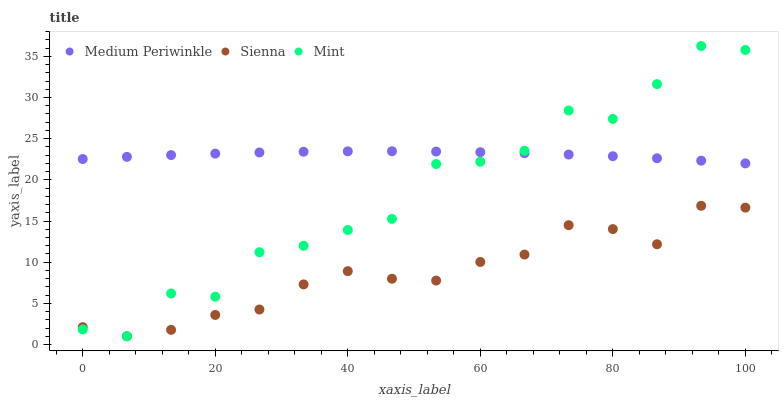Does Sienna have the minimum area under the curve?
Answer yes or no. Yes. Does Medium Periwinkle have the maximum area under the curve?
Answer yes or no. Yes. Does Mint have the minimum area under the curve?
Answer yes or no. No. Does Mint have the maximum area under the curve?
Answer yes or no. No. Is Medium Periwinkle the smoothest?
Answer yes or no. Yes. Is Mint the roughest?
Answer yes or no. Yes. Is Mint the smoothest?
Answer yes or no. No. Is Medium Periwinkle the roughest?
Answer yes or no. No. Does Sienna have the lowest value?
Answer yes or no. Yes. Does Medium Periwinkle have the lowest value?
Answer yes or no. No. Does Mint have the highest value?
Answer yes or no. Yes. Does Medium Periwinkle have the highest value?
Answer yes or no. No. Is Sienna less than Medium Periwinkle?
Answer yes or no. Yes. Is Medium Periwinkle greater than Sienna?
Answer yes or no. Yes. Does Mint intersect Medium Periwinkle?
Answer yes or no. Yes. Is Mint less than Medium Periwinkle?
Answer yes or no. No. Is Mint greater than Medium Periwinkle?
Answer yes or no. No. Does Sienna intersect Medium Periwinkle?
Answer yes or no. No. 